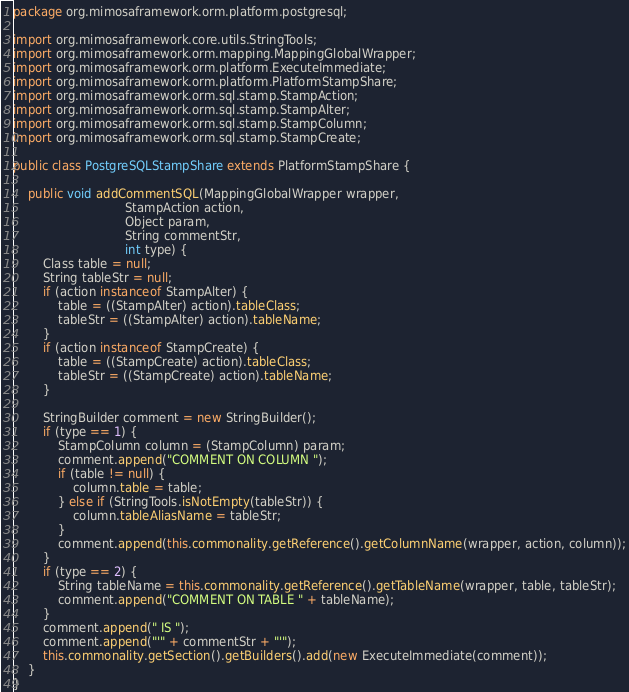Convert code to text. <code><loc_0><loc_0><loc_500><loc_500><_Java_>package org.mimosaframework.orm.platform.postgresql;

import org.mimosaframework.core.utils.StringTools;
import org.mimosaframework.orm.mapping.MappingGlobalWrapper;
import org.mimosaframework.orm.platform.ExecuteImmediate;
import org.mimosaframework.orm.platform.PlatformStampShare;
import org.mimosaframework.orm.sql.stamp.StampAction;
import org.mimosaframework.orm.sql.stamp.StampAlter;
import org.mimosaframework.orm.sql.stamp.StampColumn;
import org.mimosaframework.orm.sql.stamp.StampCreate;

public class PostgreSQLStampShare extends PlatformStampShare {

    public void addCommentSQL(MappingGlobalWrapper wrapper,
                              StampAction action,
                              Object param,
                              String commentStr,
                              int type) {
        Class table = null;
        String tableStr = null;
        if (action instanceof StampAlter) {
            table = ((StampAlter) action).tableClass;
            tableStr = ((StampAlter) action).tableName;
        }
        if (action instanceof StampCreate) {
            table = ((StampCreate) action).tableClass;
            tableStr = ((StampCreate) action).tableName;
        }

        StringBuilder comment = new StringBuilder();
        if (type == 1) {
            StampColumn column = (StampColumn) param;
            comment.append("COMMENT ON COLUMN ");
            if (table != null) {
                column.table = table;
            } else if (StringTools.isNotEmpty(tableStr)) {
                column.tableAliasName = tableStr;
            }
            comment.append(this.commonality.getReference().getColumnName(wrapper, action, column));
        }
        if (type == 2) {
            String tableName = this.commonality.getReference().getTableName(wrapper, table, tableStr);
            comment.append("COMMENT ON TABLE " + tableName);
        }
        comment.append(" IS ");
        comment.append("'" + commentStr + "'");
        this.commonality.getSection().getBuilders().add(new ExecuteImmediate(comment));
    }
}
</code> 